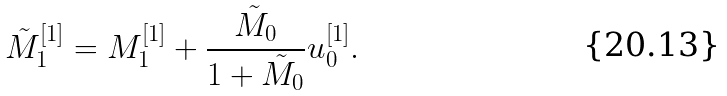<formula> <loc_0><loc_0><loc_500><loc_500>\tilde { M } _ { 1 } ^ { [ 1 ] } = M _ { 1 } ^ { [ 1 ] } + \frac { \tilde { M } _ { 0 } } { 1 + \tilde { M } _ { 0 } } u _ { 0 } ^ { [ 1 ] } .</formula> 